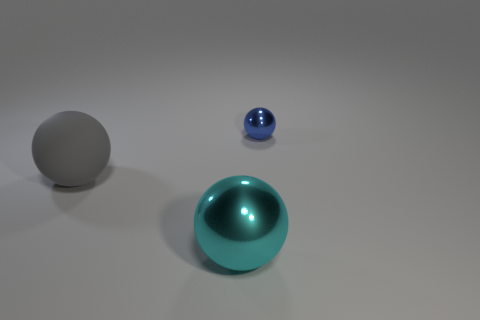How does the size of the smaller blue sphere compare to the larger teal sphere? The smaller blue sphere appears to be less than half the size of the larger teal sphere when observing their diameters. 